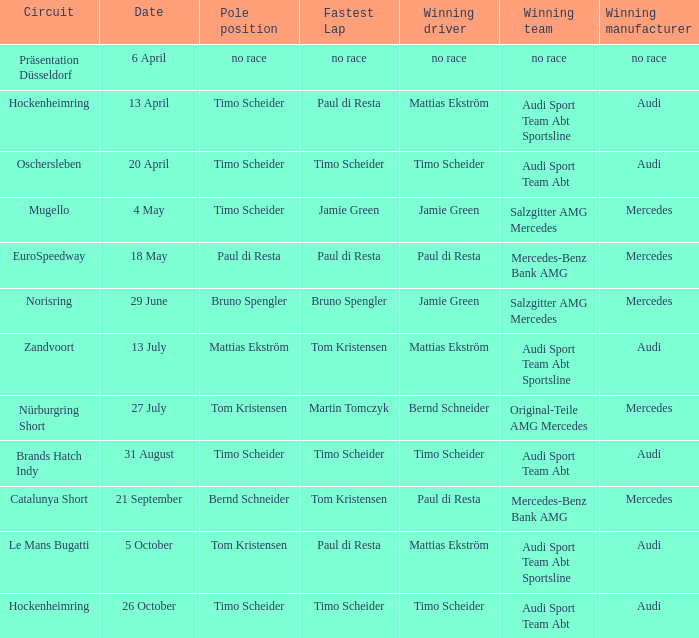Which team emerged victorious in the race on august 31, featuring audi as the winning manufacturer and timo scheider as the winning driver? Audi Sport Team Abt. 